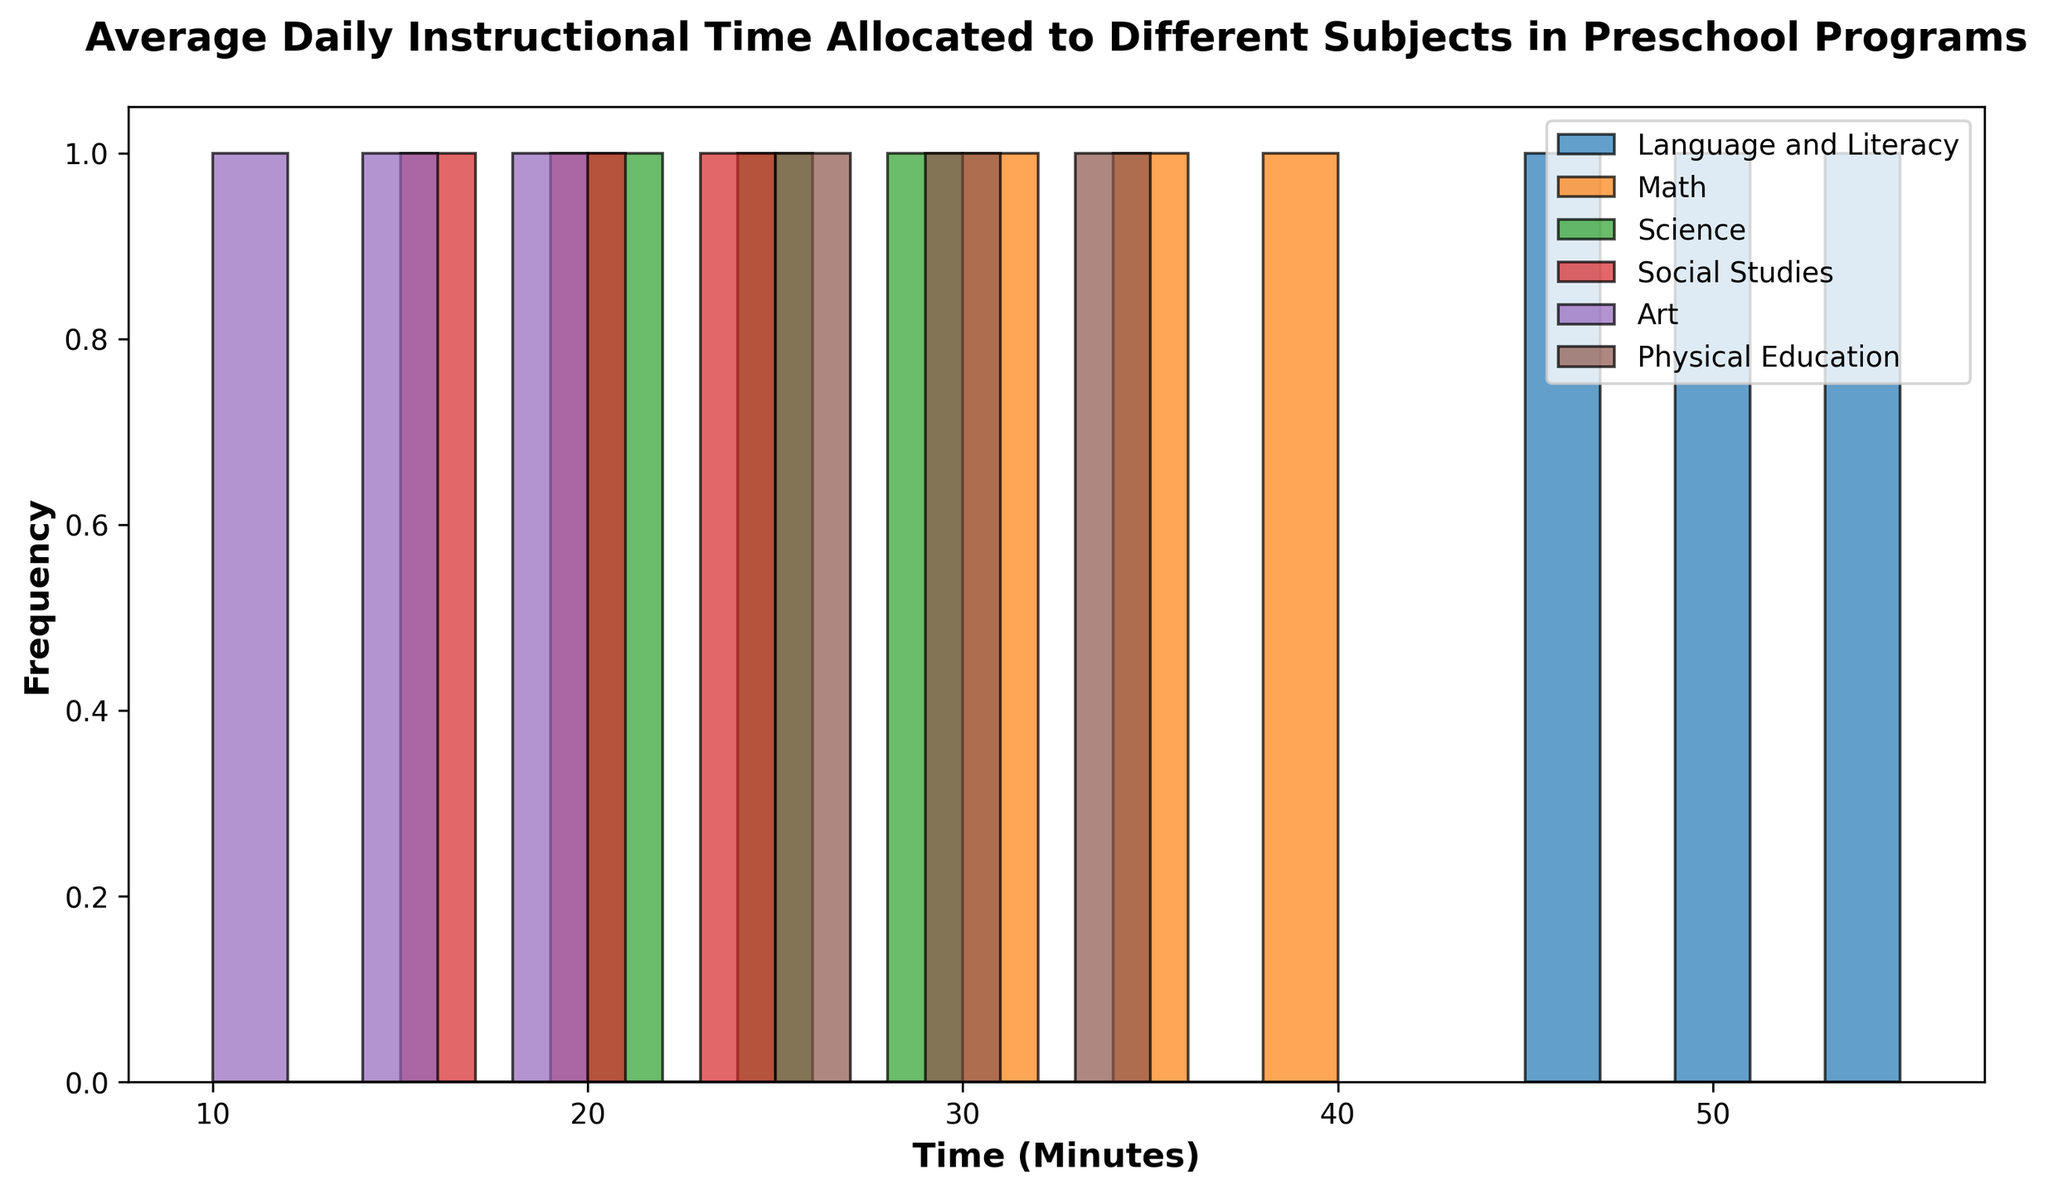What's the most frequently allocated time range for Math? By looking at the histogram, we can see the bins for Math are grouped around certain time ranges. The tallest bin corresponds to the time range that appears the most frequently.
Answer: 30-35 minutes Which subject allocates the least average instructional time? To determine this, check which subject's histogram bins have lower time values on average. Art has the lowest range of values compared to others, primarily between 10 to 20 minutes.
Answer: Art Is the instructional time for Physical Education more varied than for Science? To answer this, we compare the spread (width) of the bins for both subjects. Physical Education covers a range from 25 to 35 minutes, while Science ranges from 20 to 30 minutes, indicating a similar spread.
Answer: No How do the frequencies of Language and Literacy bins compare to those of Social Studies? To compare, examine the height of the histogram bins for both subjects. The bins for Language and Literacy are generally higher than those for Social Studies, indicating higher frequencies for Language and Literacy times.
Answer: Higher What is the range of times allocated for Social Studies? By examining the bins for Social Studies, we see they range from the lowest value to the highest value in the data. The bins range from 15 to 25 minutes.
Answer: 15-25 minutes Which subject has the closest average instructional time to that of Science? Calculate the average time for each subject by summing its time values and dividing by the count. Compare these averages, and Math has a close average value to Science.
Answer: Math Which subject has the widest distribution of time allocations? To determine which subject has the widest spread of time bins, select the one with the largest range. Language and Literacy spans from 45 to 55 minutes, showcasing the widest distribution.
Answer: Language and Literacy How many subjects allocate less than 25 minutes on average? First, calculate the average time for each subject. Subjects with averages below 25 minutes are Social Studies and Art. Count these subjects.
Answer: 2 